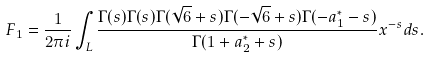<formula> <loc_0><loc_0><loc_500><loc_500>F _ { 1 } = \frac { 1 } { 2 \pi i } \int _ { L } \frac { \Gamma ( s ) \Gamma ( s ) \Gamma ( \sqrt { 6 } + s ) \Gamma ( - \sqrt { 6 } + s ) \Gamma ( - a _ { 1 } ^ { * } - s ) } { \Gamma ( 1 + a _ { 2 } ^ { * } + s ) } x ^ { - s } d s .</formula> 